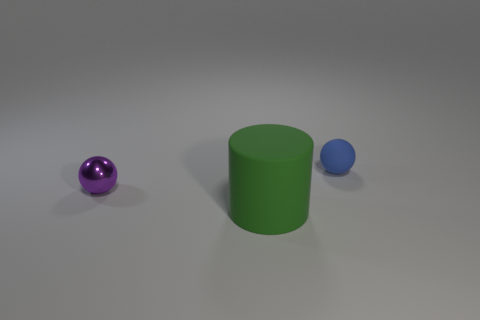How many tiny purple metallic balls are on the left side of the object that is on the left side of the big green cylinder?
Offer a terse response. 0. Are there any purple metallic objects of the same shape as the tiny blue thing?
Keep it short and to the point. Yes. What is the color of the small thing that is to the right of the thing left of the large green rubber thing?
Keep it short and to the point. Blue. Is the number of big green matte objects greater than the number of balls?
Your answer should be very brief. No. How many rubber balls are the same size as the purple metallic object?
Provide a short and direct response. 1. Is the material of the tiny blue ball the same as the sphere left of the large object?
Provide a succinct answer. No. Is the number of cylinders less than the number of things?
Keep it short and to the point. Yes. What shape is the small blue thing that is made of the same material as the big cylinder?
Provide a succinct answer. Sphere. There is a blue sphere that is to the right of the small sphere on the left side of the cylinder; what number of large green matte things are right of it?
Provide a succinct answer. 0. There is a thing that is to the left of the tiny blue sphere and right of the small metallic object; what is its shape?
Your answer should be compact. Cylinder. 